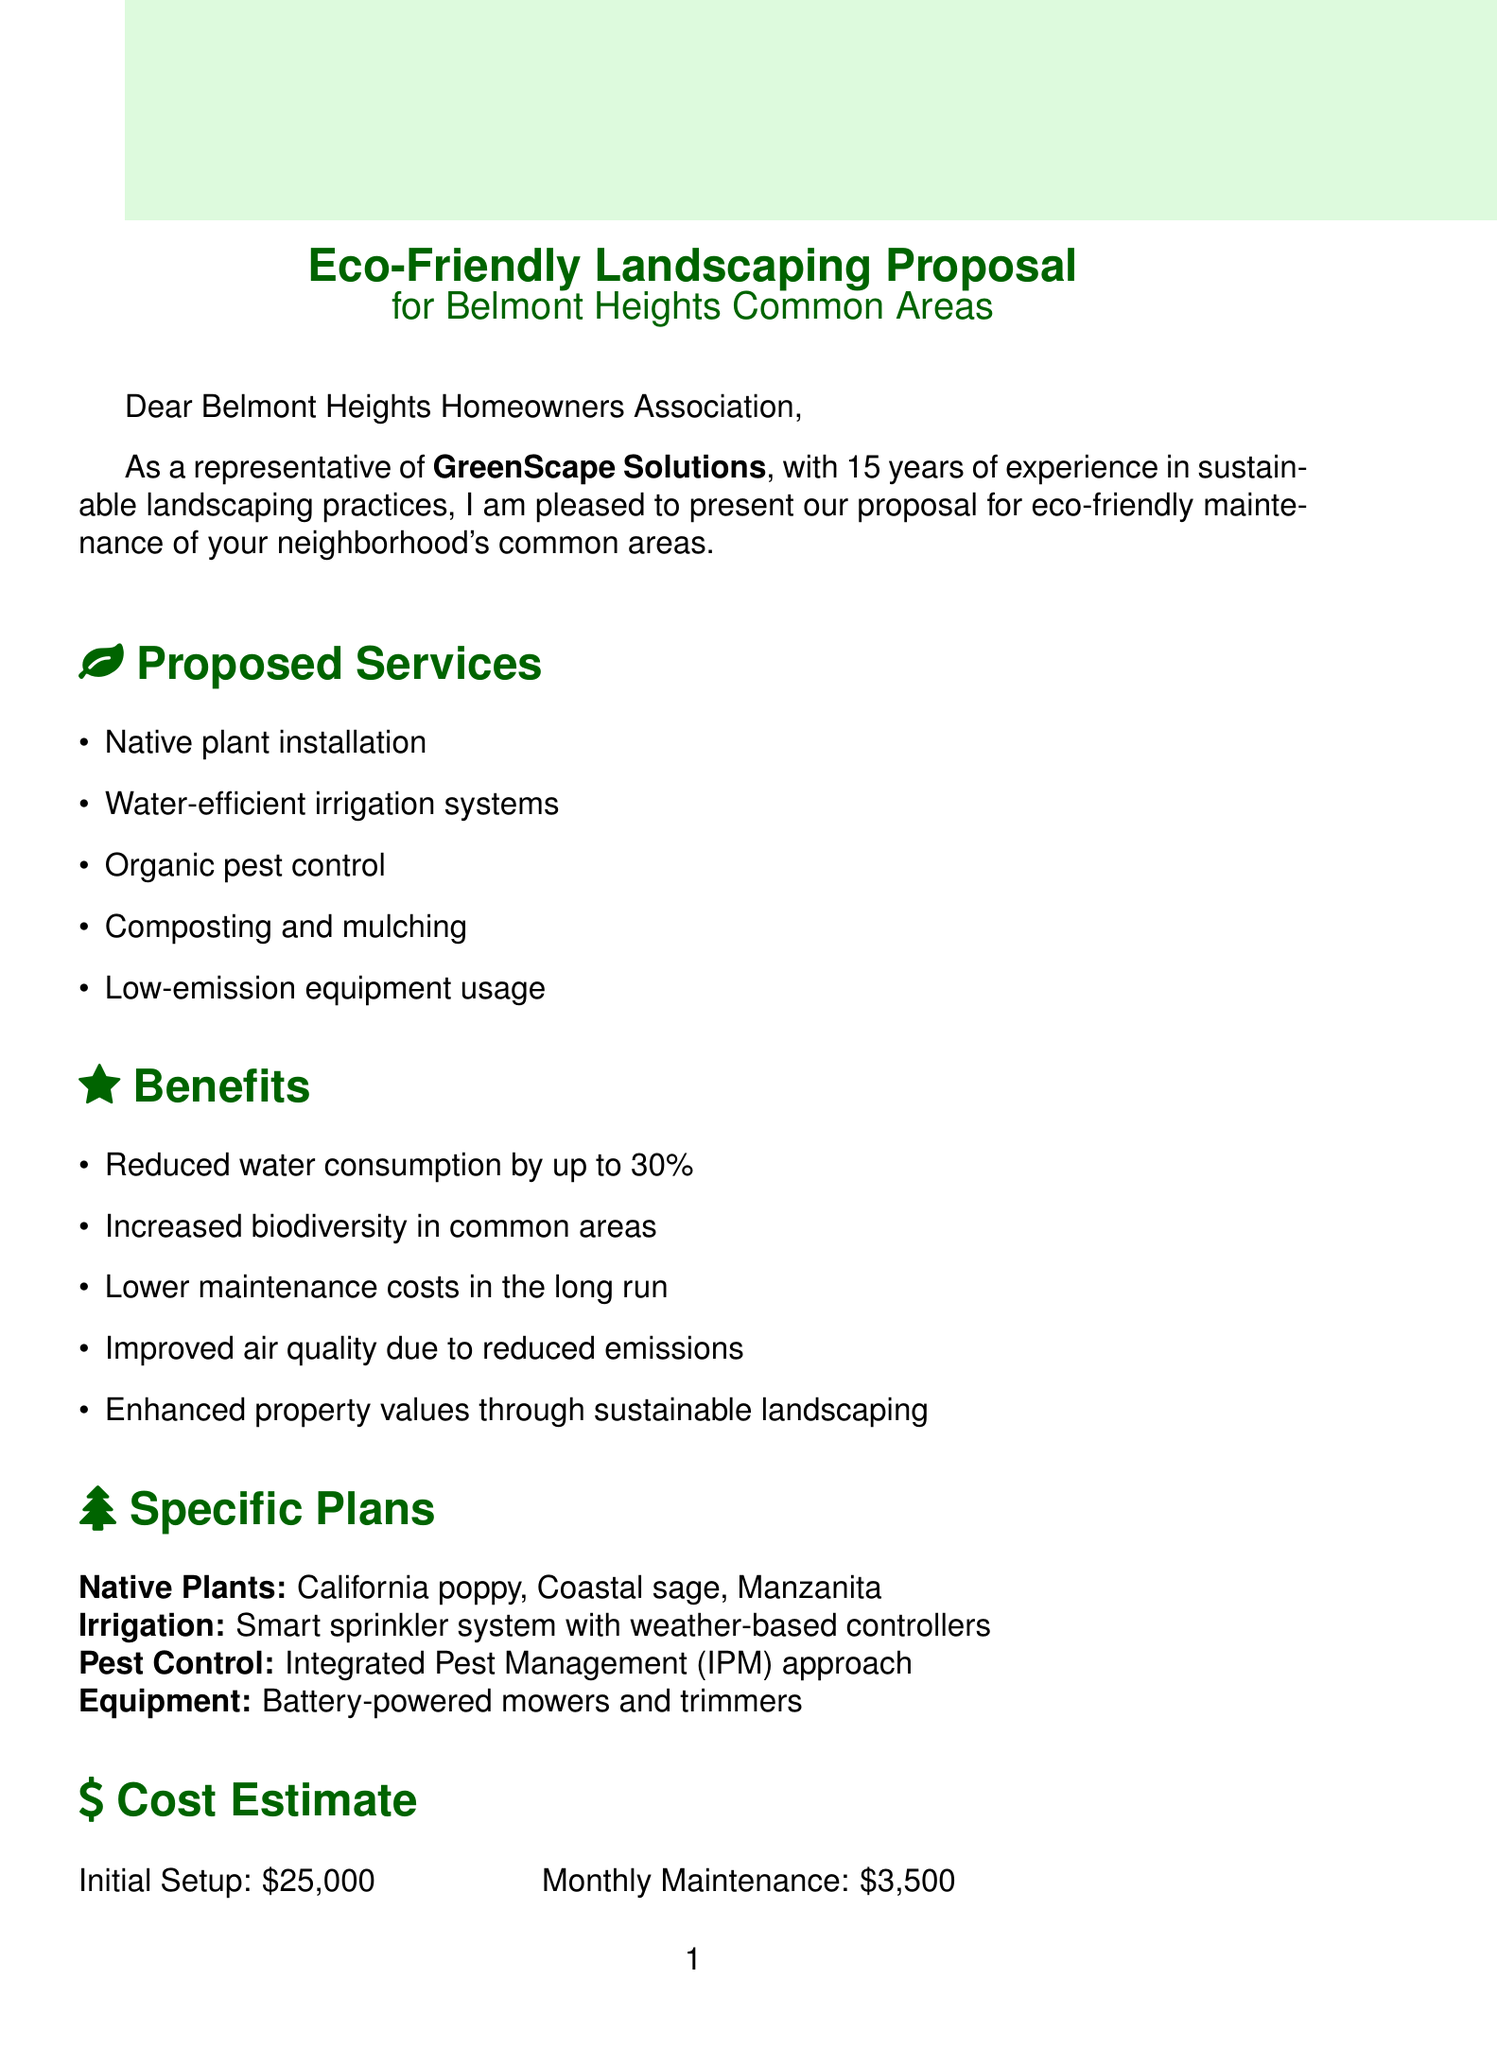What is the company name in the proposal? The company name is mentioned in the introduction section of the document as GreenScape Solutions.
Answer: GreenScape Solutions How many years of experience does the company have? The document states that the company has 15 years of experience in sustainable landscaping practices.
Answer: 15 What is the initial setup cost? The document provides a cost estimate showing the initial setup cost as $25,000.
Answer: $25,000 Which native plants are proposed for installation? The section on specific plans lists California poppy, Coastal sage, and Manzanita as the native plants proposed for installation.
Answer: California poppy, Coastal sage, Manzanita What is one benefit of the proposed services? The benefits section outlines various advantages, one being reduced water consumption.
Answer: Reduced water consumption by up to 30% What type of irrigation system is proposed? The document specifies a smart sprinkler system with weather-based controllers for irrigation.
Answer: Smart sprinkler system with weather-based controllers Who is the lead landscape architect? The contact information section identifies Sarah Green as the lead landscape architect.
Answer: Sarah Green What sustainability certifications does the company hold? The document lists LEED Green Associate and Sustainable Landscapes Program certification under sustainability certifications.
Answer: LEED Green Associate, Sustainable Landscapes Program certification Which client references are provided in the proposal? The proposal mentions Oakwood Estates HOA and Sunnyvale Community Association as client references.
Answer: Oakwood Estates HOA, Sunnyvale Community Association 